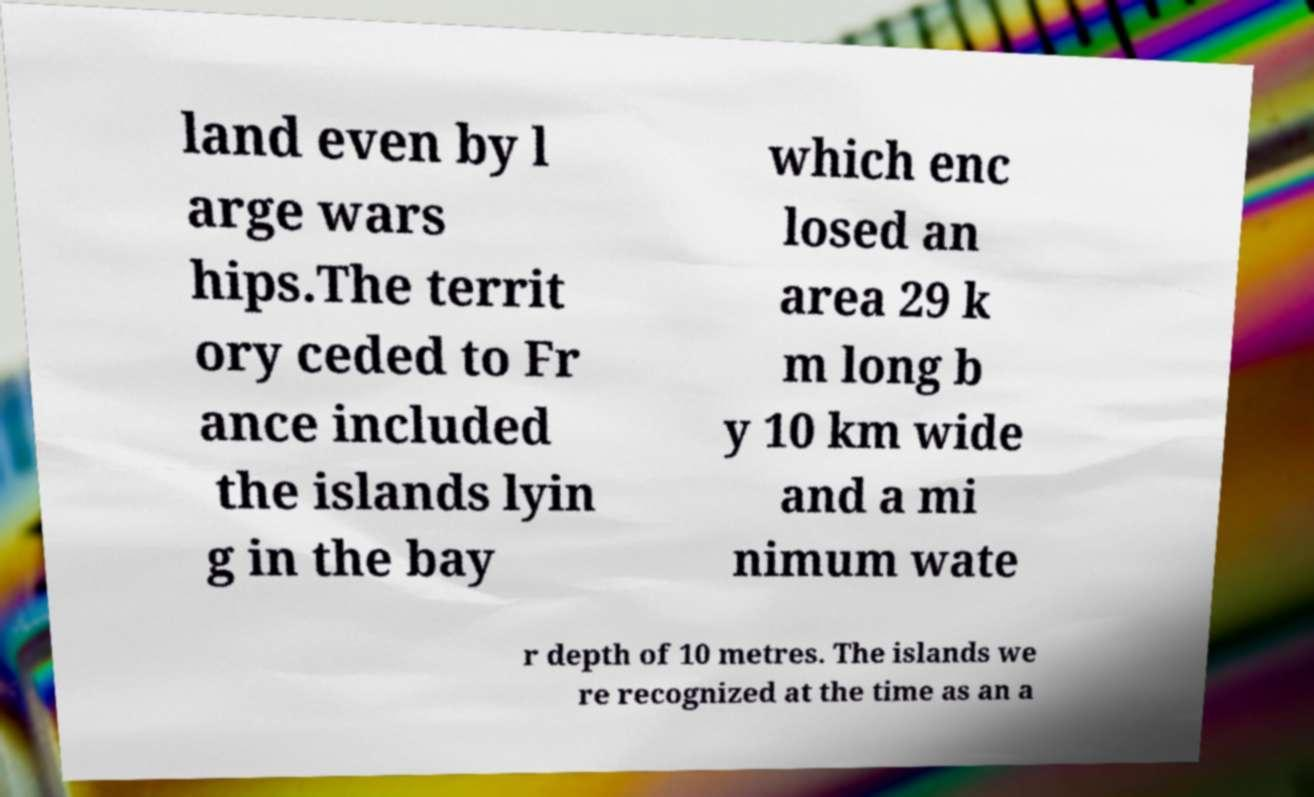What messages or text are displayed in this image? I need them in a readable, typed format. land even by l arge wars hips.The territ ory ceded to Fr ance included the islands lyin g in the bay which enc losed an area 29 k m long b y 10 km wide and a mi nimum wate r depth of 10 metres. The islands we re recognized at the time as an a 